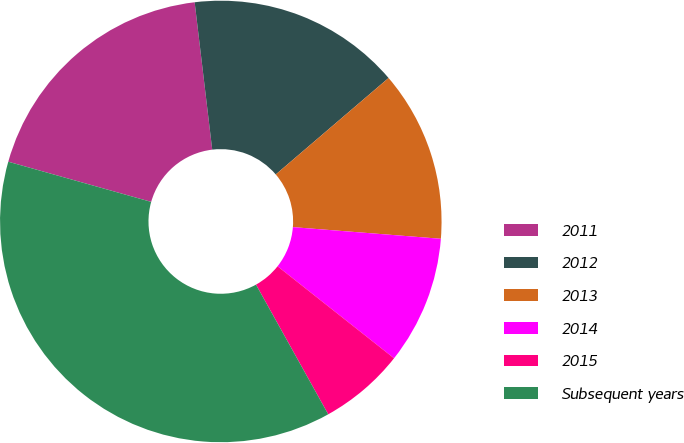<chart> <loc_0><loc_0><loc_500><loc_500><pie_chart><fcel>2011<fcel>2012<fcel>2013<fcel>2014<fcel>2015<fcel>Subsequent years<nl><fcel>18.75%<fcel>15.63%<fcel>12.51%<fcel>9.39%<fcel>6.27%<fcel>37.45%<nl></chart> 